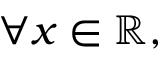Convert formula to latex. <formula><loc_0><loc_0><loc_500><loc_500>\forall x \in \mathbb { R } ,</formula> 